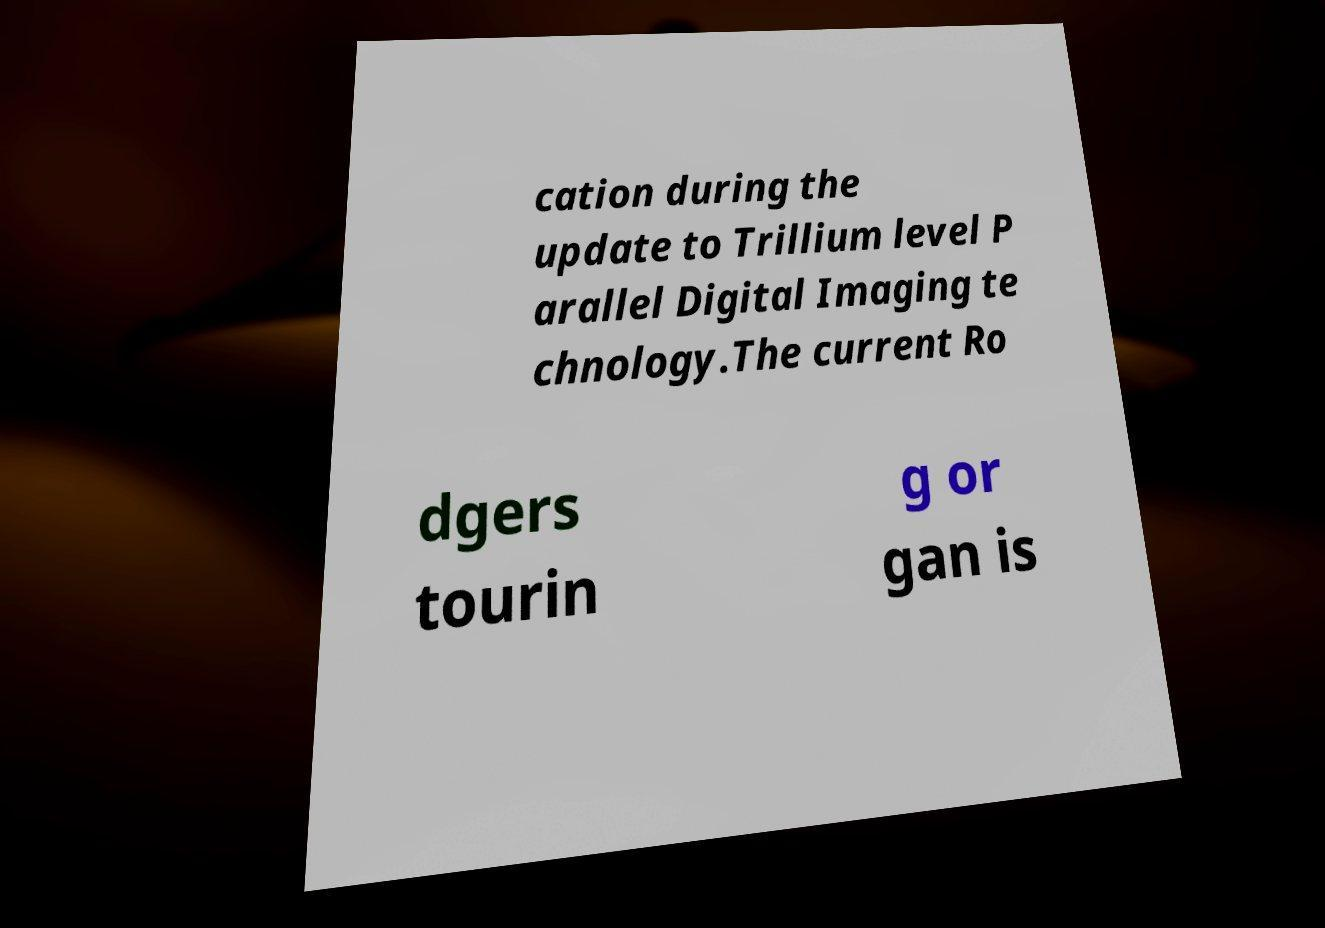Could you extract and type out the text from this image? cation during the update to Trillium level P arallel Digital Imaging te chnology.The current Ro dgers tourin g or gan is 